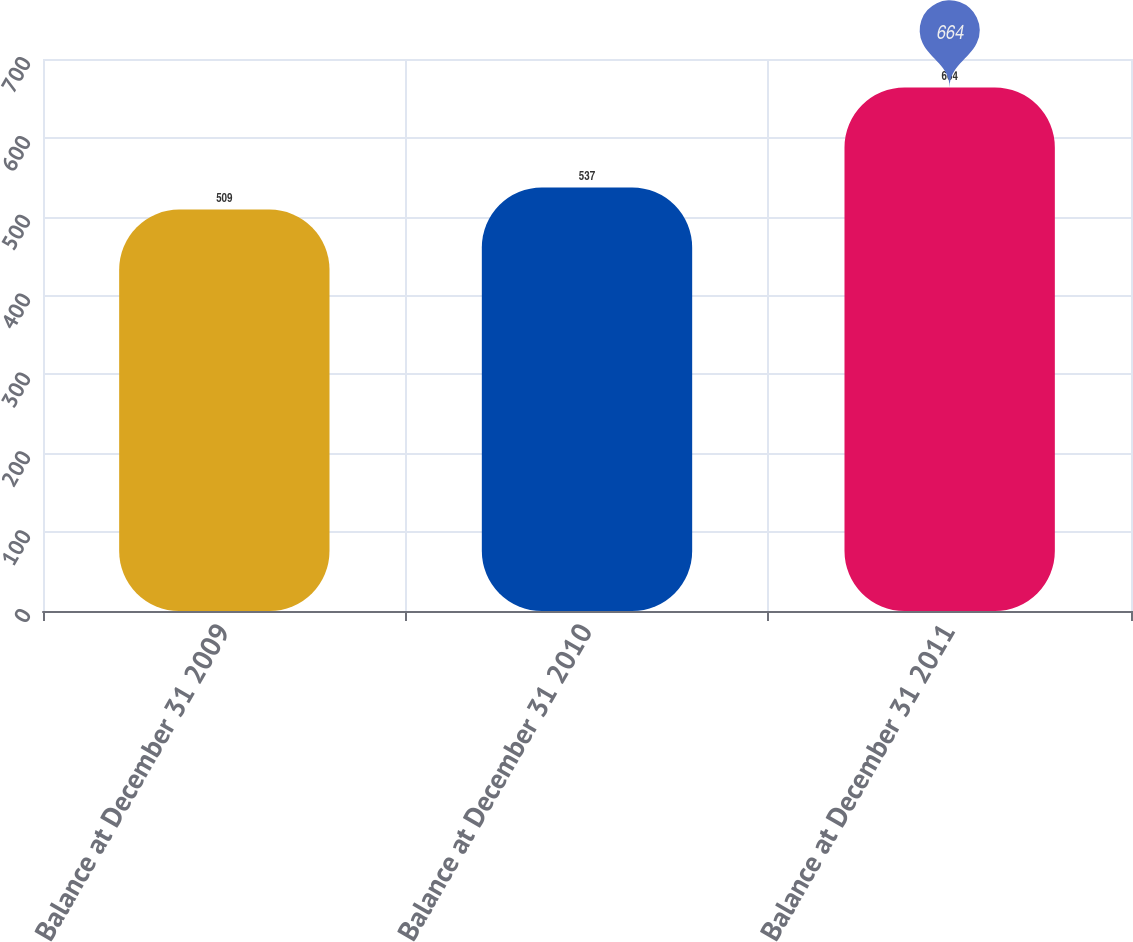<chart> <loc_0><loc_0><loc_500><loc_500><bar_chart><fcel>Balance at December 31 2009<fcel>Balance at December 31 2010<fcel>Balance at December 31 2011<nl><fcel>509<fcel>537<fcel>664<nl></chart> 